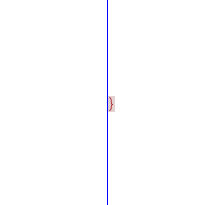<code> <loc_0><loc_0><loc_500><loc_500><_CSS_>}</code> 